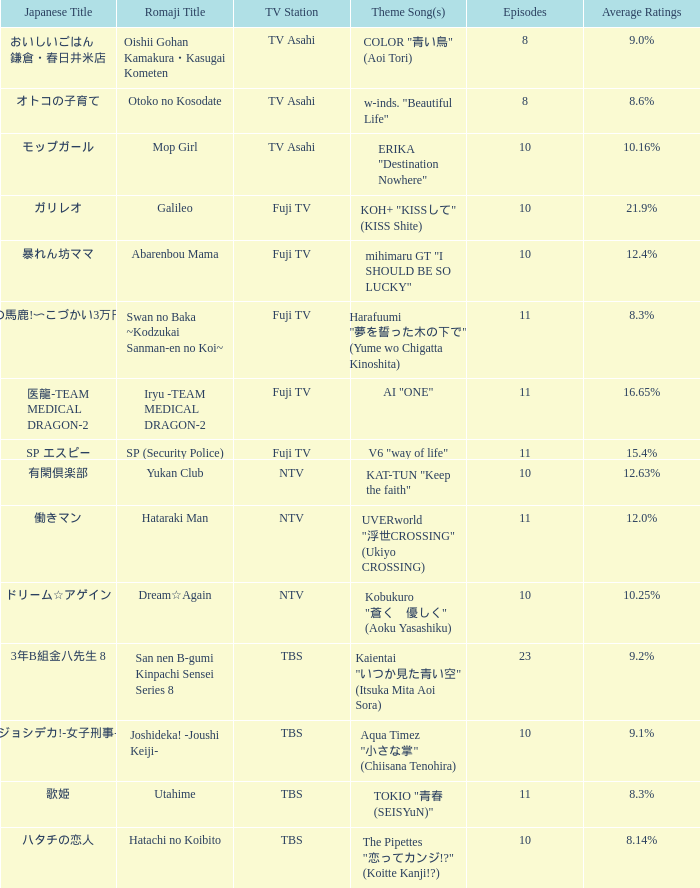What is the theme song of iryu - team medical dragon - 2? AI "ONE". 